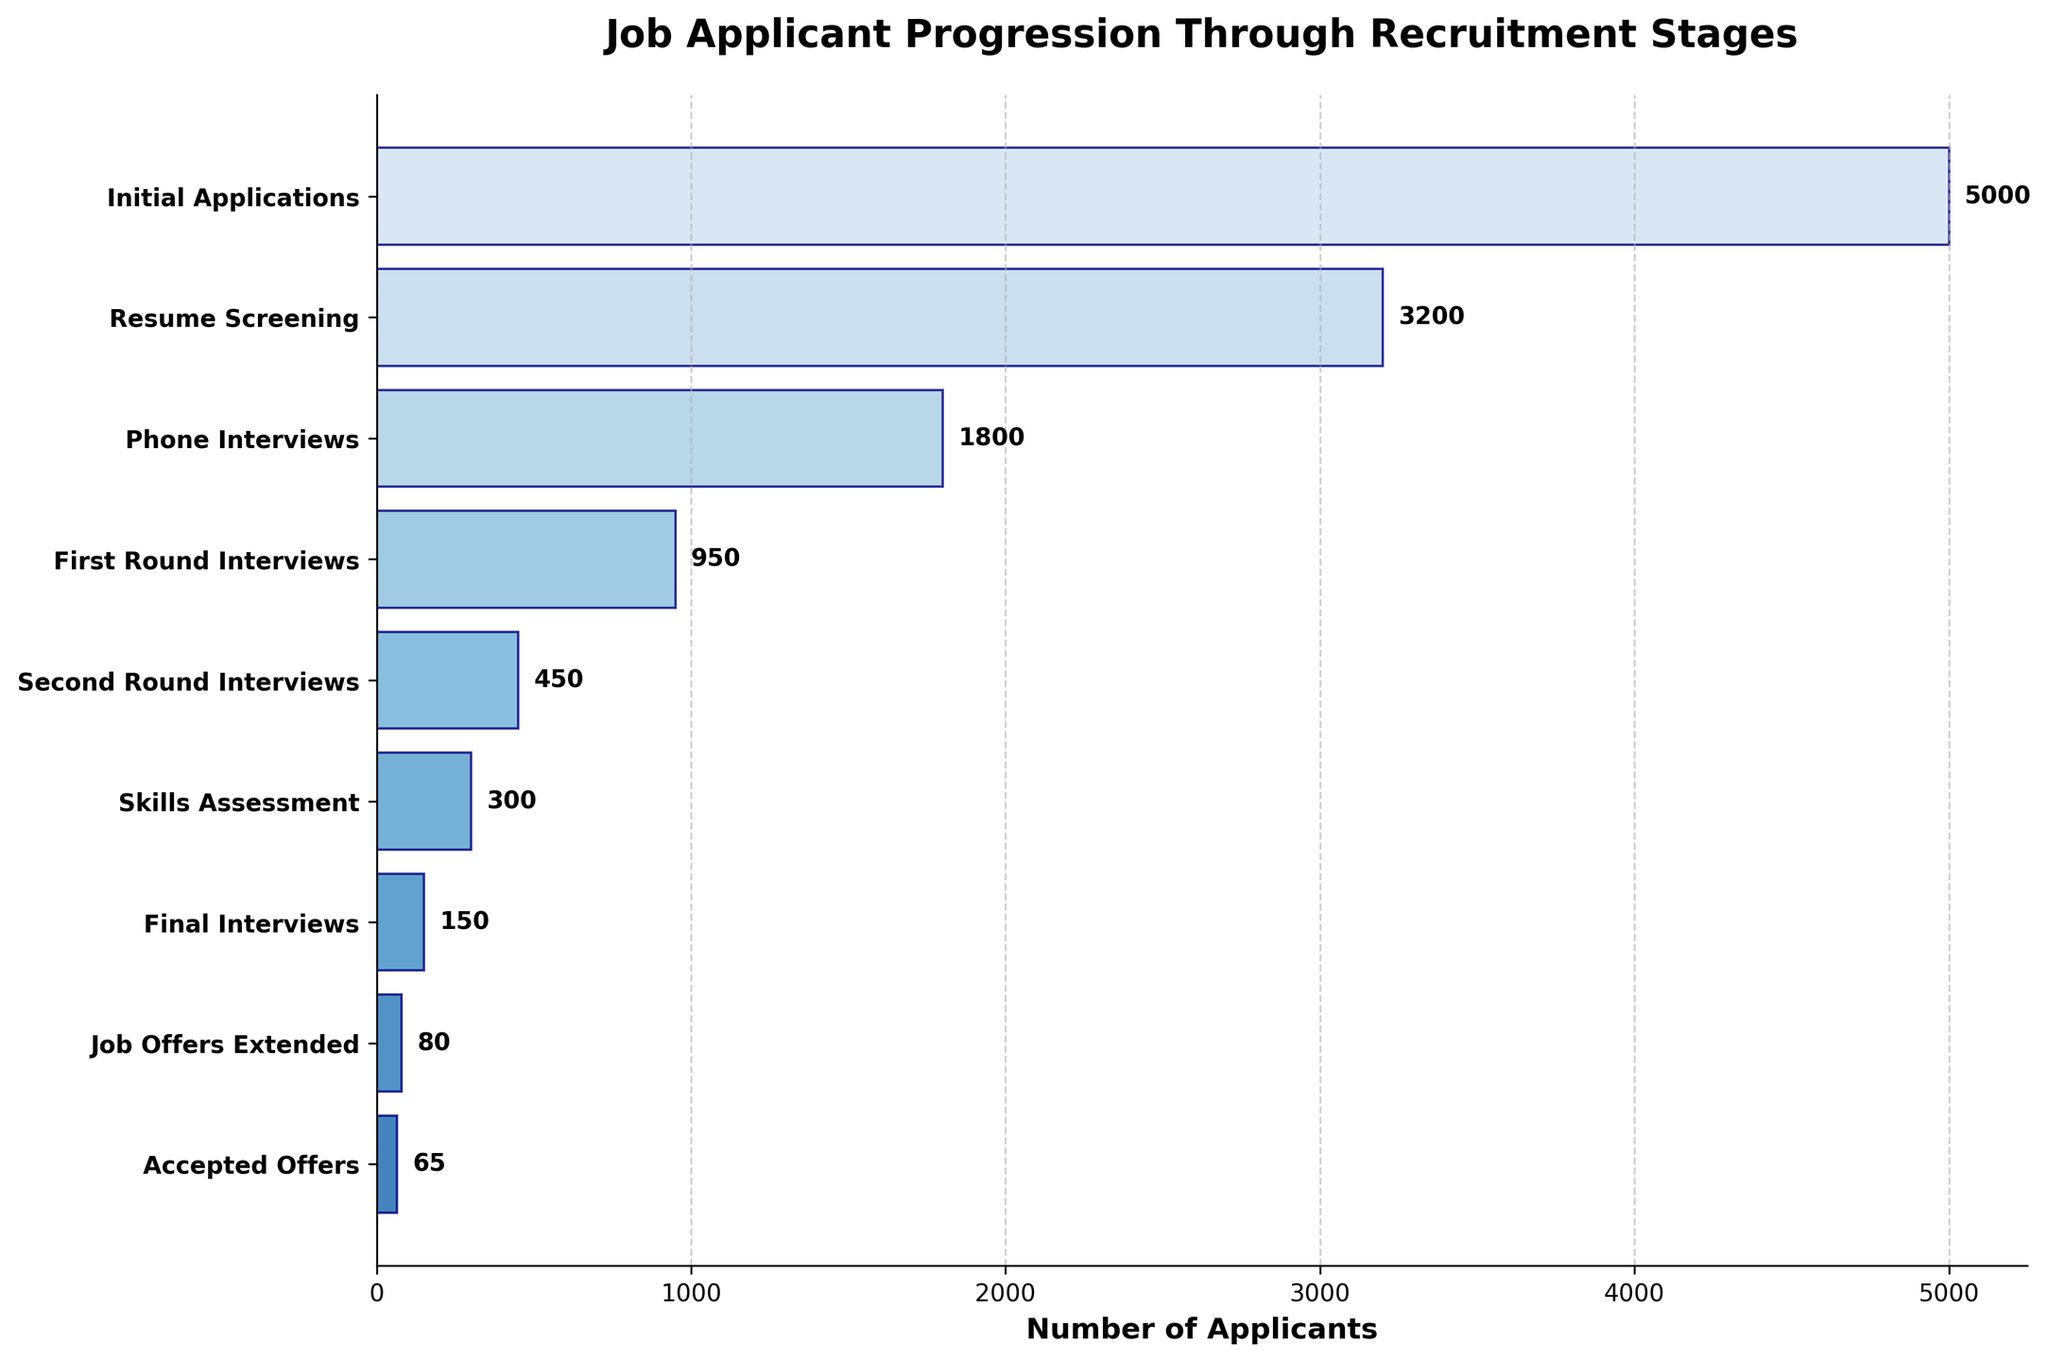What is the title of the chart? The title is located at the top of the figure and it states the purpose or topic of the chart. Here, it clearly indicates the subject of the funnel chart.
Answer: Job Applicant Progression Through Recruitment Stages How many stages are there in the recruitment process according to the chart? Count the number of horizontal bars or categories listed along the y-axis. This gives the number of stages.
Answer: 8 How many applicants initially applied for the job? Look at the number labeled beside the corresponding stage "Initial Applications" on the figure.
Answer: 5000 What is the number of applicants who made it to the Phone Interviews stage? Refer to the quantity labeled next to "Phone Interviews" on the y-axis.
Answer: 1800 How many applicants received job offers? Identify and read the number next to "Job Offers Extended" on the y-axis.
Answer: 80 How many applicants accepted the job offers? Check the number adjacent to the stage "Accepted Offers" on the funnel chart.
Answer: 65 